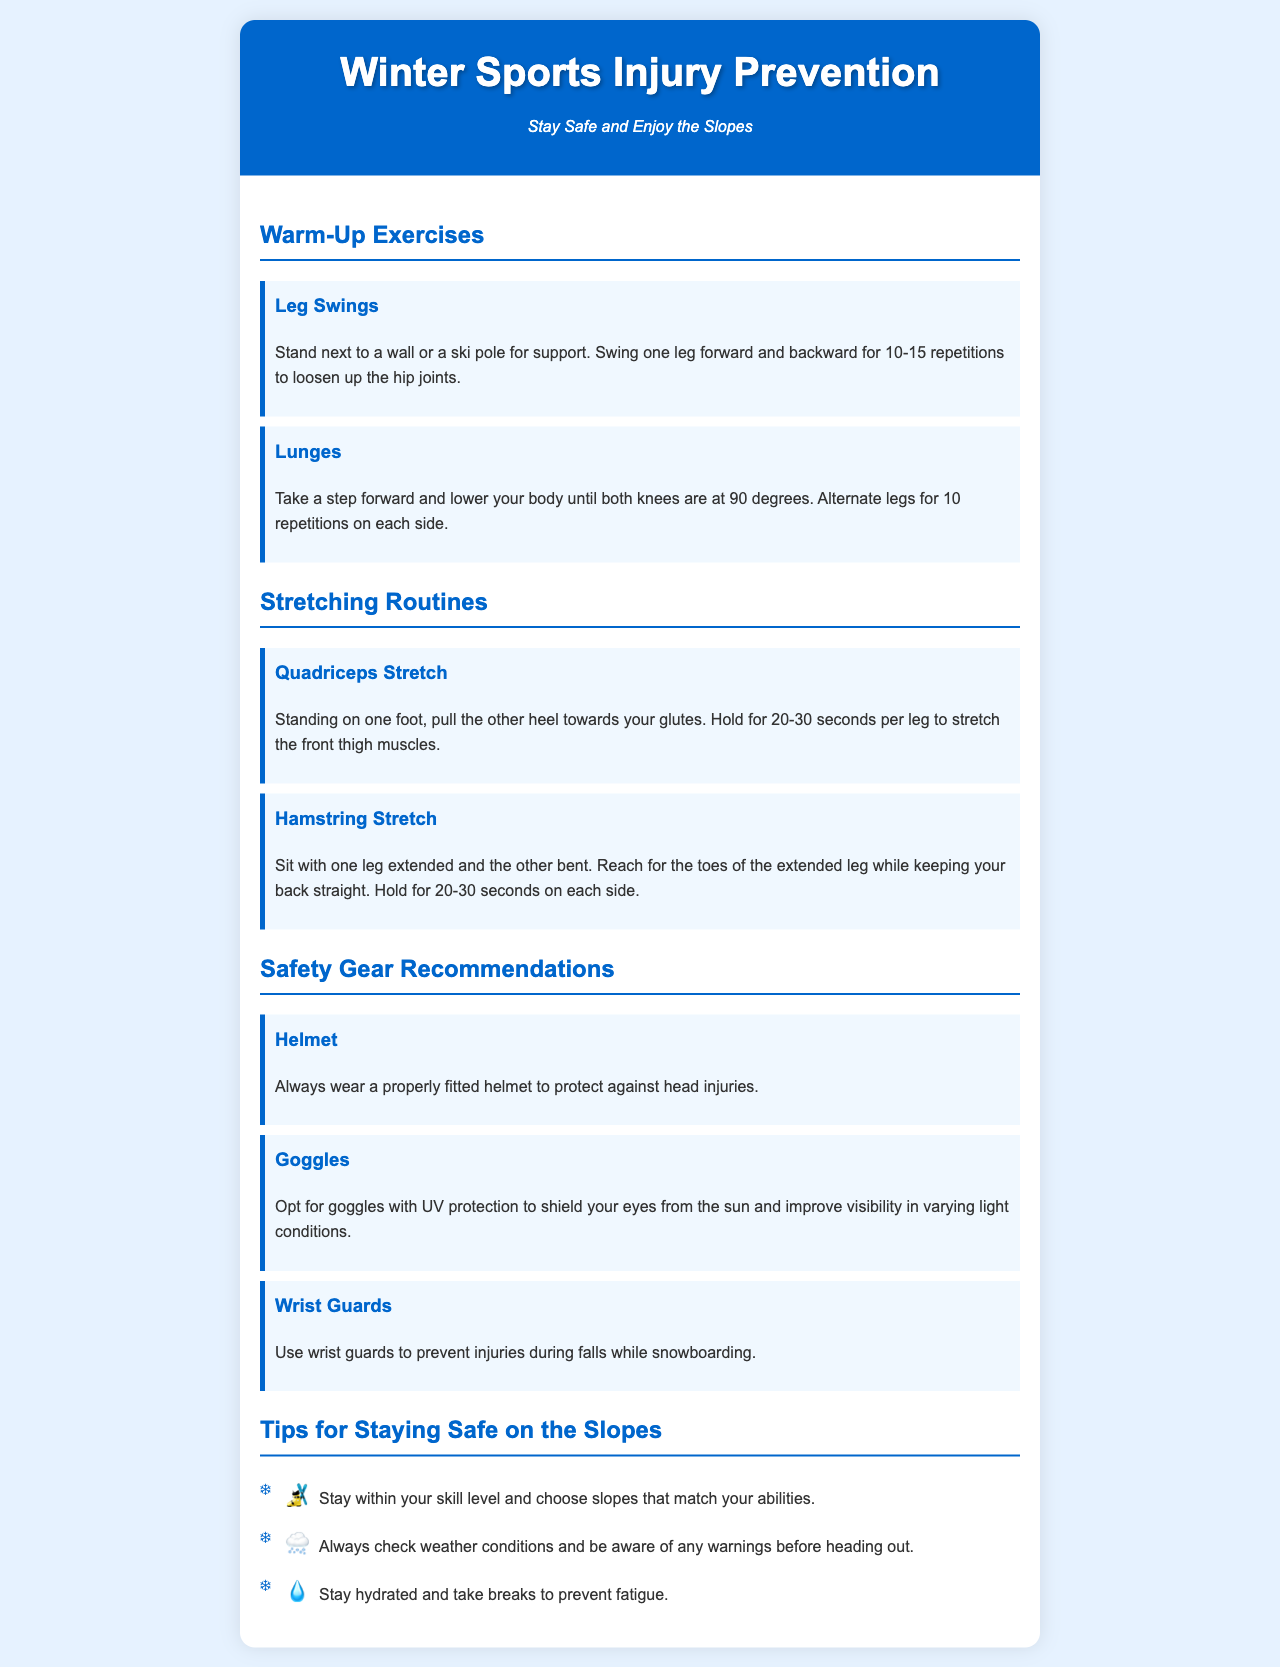What are the two warm-up exercises mentioned? The exercises listed under Warm-Up Exercises are Leg Swings and Lunges.
Answer: Leg Swings, Lunges How long should you hold the Quadriceps Stretch? The document specifies to hold the Quadriceps Stretch for 20-30 seconds per leg.
Answer: 20-30 seconds What safety gear is recommended for head protection? The document mentions wearing a Helmet for head protection.
Answer: Helmet What is one tip for staying safe on the slopes? The document provides several tips, one of which is to stay within your skill level.
Answer: Stay within your skill level How many repetitions are recommended for Lunges? The document suggests doing 10 repetitions on each side for Lunges.
Answer: 10 